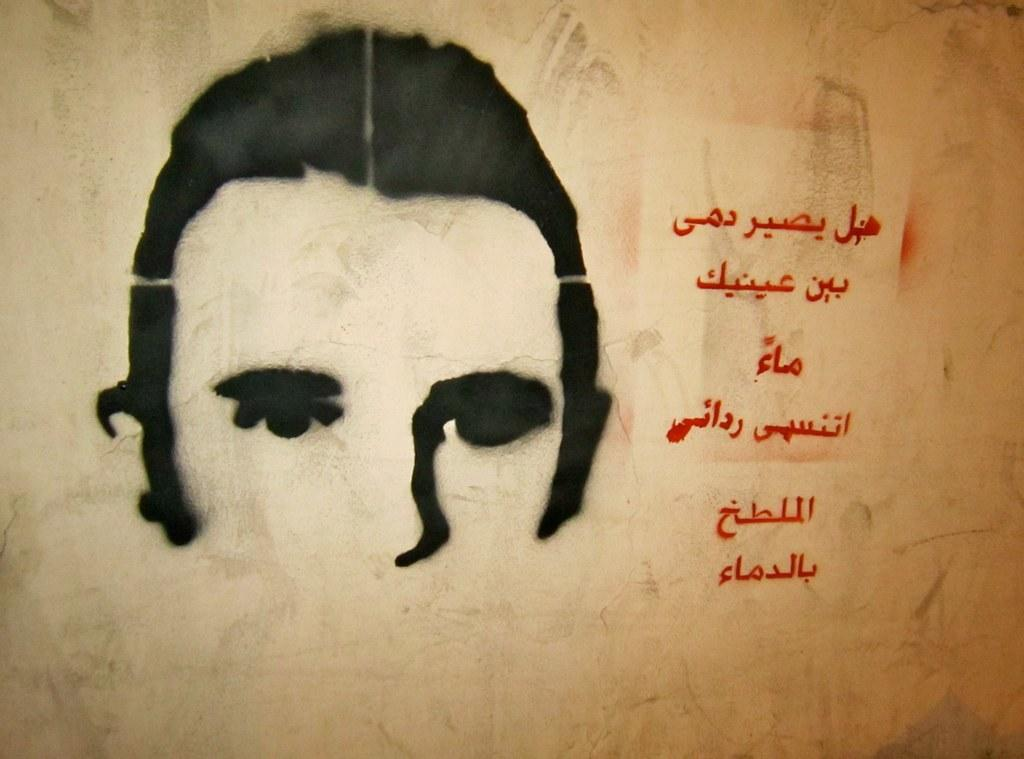What is on the wall in the image? There is a painting on the wall in the image. What grade does the chicken in the painting receive for its performance? There is no chicken present in the image, as it only features a painting on the wall. 